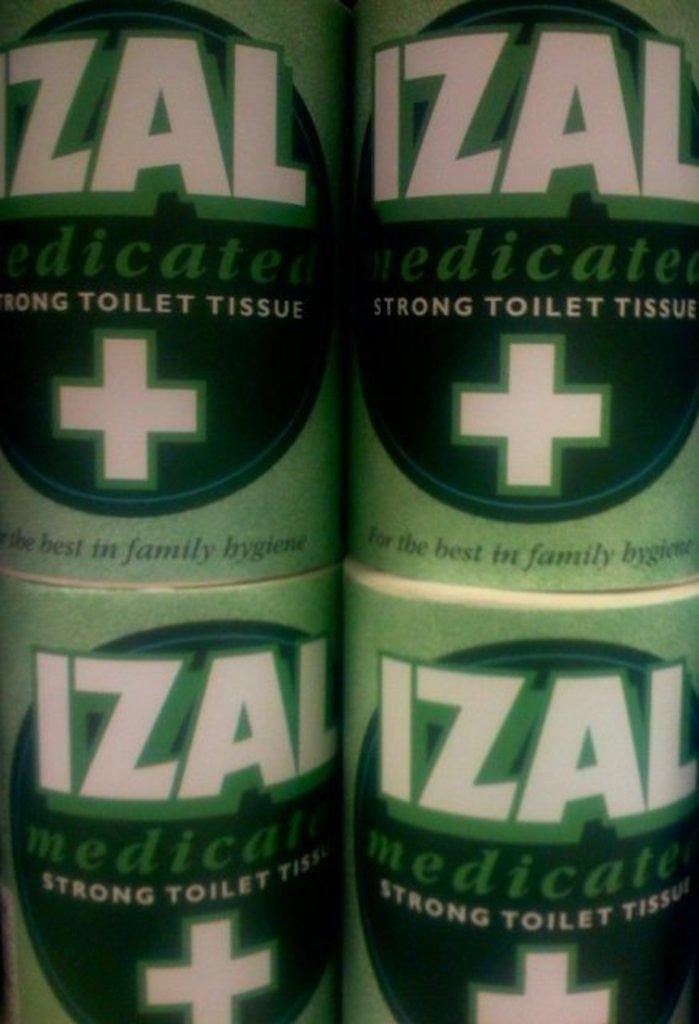<image>
Offer a succinct explanation of the picture presented. Four green rolls of Izal strong toilet tissue 